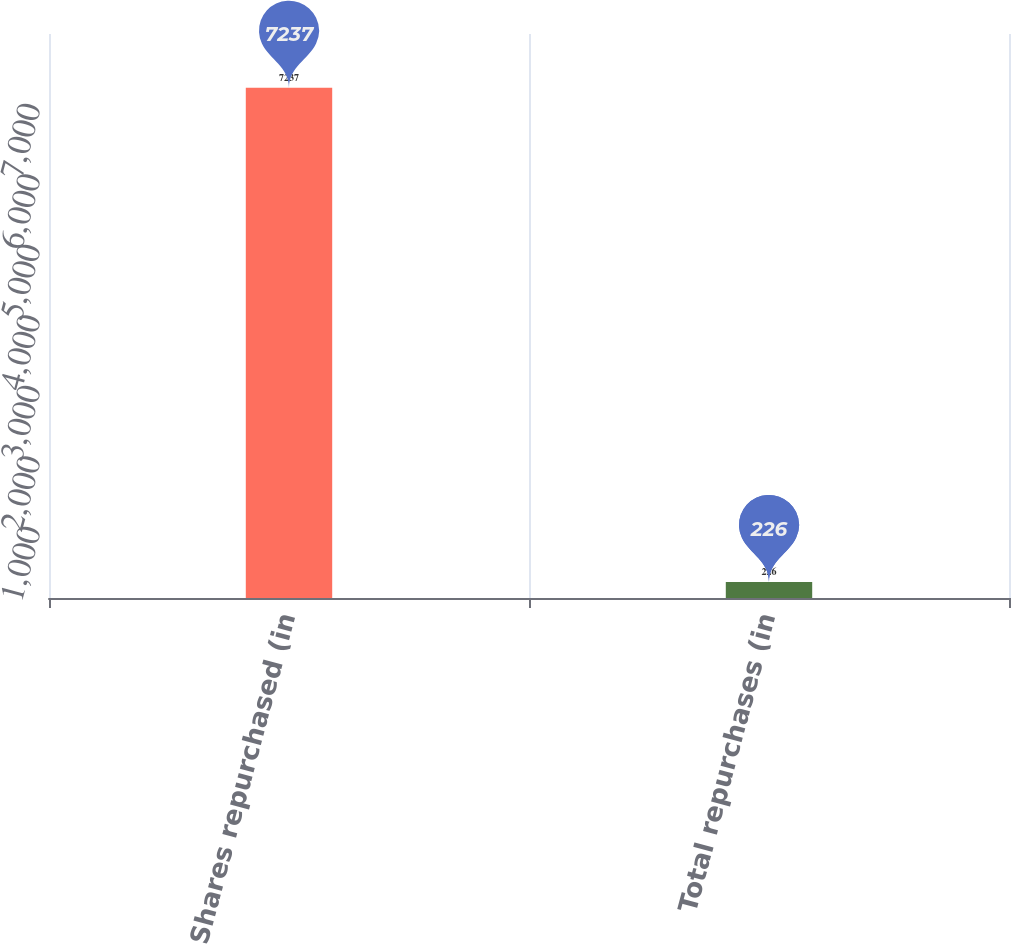Convert chart to OTSL. <chart><loc_0><loc_0><loc_500><loc_500><bar_chart><fcel>Shares repurchased (in<fcel>Total repurchases (in<nl><fcel>7237<fcel>226<nl></chart> 